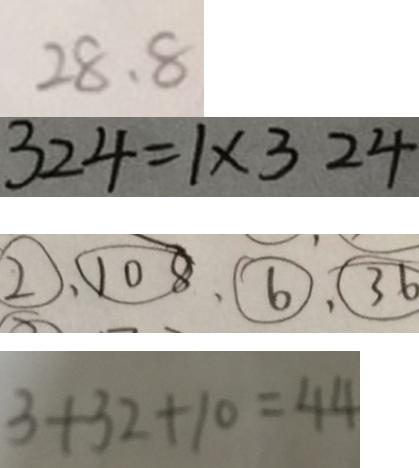Convert formula to latex. <formula><loc_0><loc_0><loc_500><loc_500>2 8 . 8 
 3 2 4 = 1 \times 3 2 4 
 \textcircled { 2 } 、 \textcircled { 1 0 8 } 、 \textcircled { 6 } 、 \textcircled { 3 6 } 
 3 + 3 2 + 1 0 = 4 4</formula> 